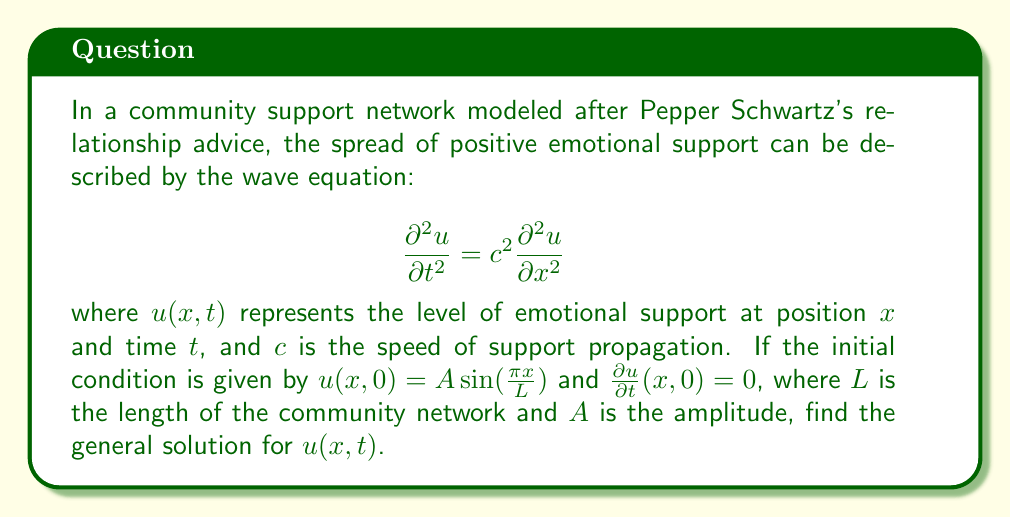Show me your answer to this math problem. To solve this wave equation problem, we'll follow these steps:

1) The general solution for the wave equation with the given initial conditions is of the form:

   $$u(x,t) = F(x-ct) + G(x+ct)$$

2) Given the initial condition $u(x,0) = A \sin(\frac{\pi x}{L})$, we can deduce:

   $$F(x) + G(x) = A \sin(\frac{\pi x}{L})$$

3) From the second initial condition $\frac{\partial u}{\partial t}(x,0) = 0$, we get:

   $$-cF'(x) + cG'(x) = 0$$
   
   This implies $F'(x) = G'(x)$, so $F(x) = G(x) + constant$

4) Combining steps 2 and 3:

   $$2F(x) = A \sin(\frac{\pi x}{L})$$
   
   $$F(x) = \frac{A}{2} \sin(\frac{\pi x}{L})$$
   
   $$G(x) = \frac{A}{2} \sin(\frac{\pi x}{L})$$

5) Substituting these back into the general solution:

   $$u(x,t) = \frac{A}{2} \sin(\frac{\pi (x-ct)}{L}) + \frac{A}{2} \sin(\frac{\pi (x+ct)}{L})$$

6) Using the trigonometric identity for the sum of sines:

   $$\sin A + \sin B = 2 \sin(\frac{A+B}{2}) \cos(\frac{A-B}{2})$$

   We get:

   $$u(x,t) = A \sin(\frac{\pi x}{L}) \cos(\frac{\pi ct}{L})$$

This solution represents a standing wave in the community support network, where the amplitude of emotional support varies sinusoidally in space and oscillates in time.
Answer: $$u(x,t) = A \sin(\frac{\pi x}{L}) \cos(\frac{\pi ct}{L})$$ 